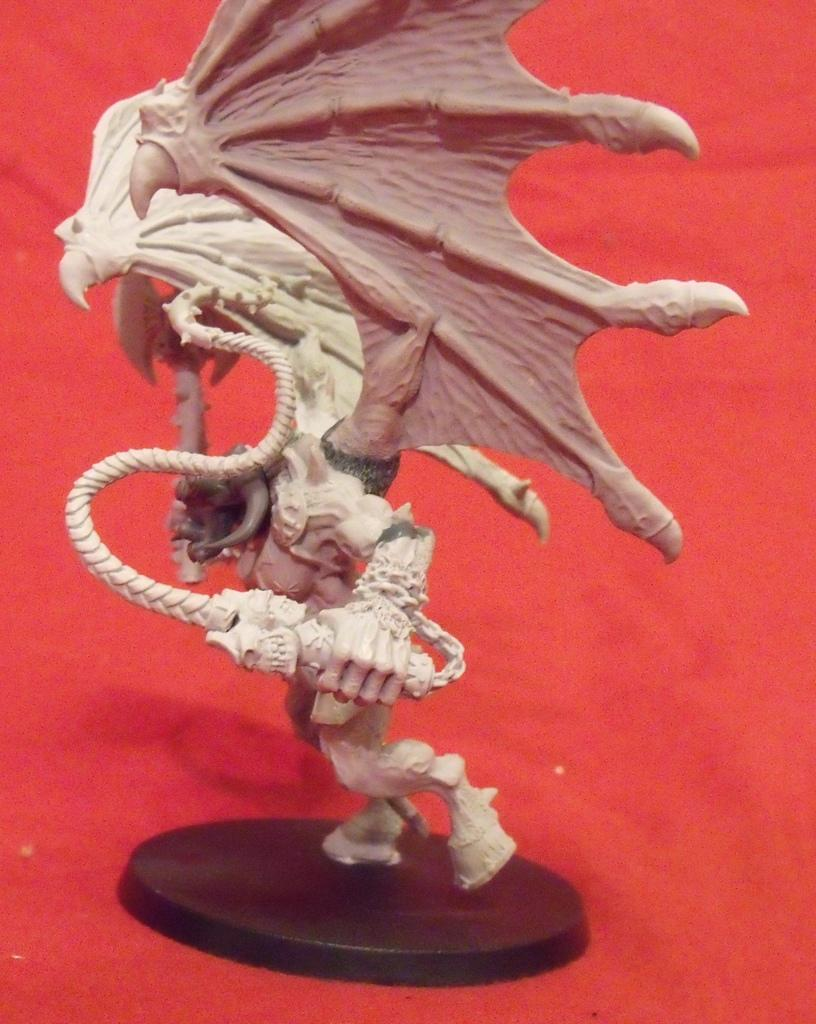What is the main subject of the image? There is a sculpture in the image. What is the sculpture placed on? The sculpture is on a red color mat. What type of trail can be seen in the image? There is no trail present in the image; it features a sculpture on a red color mat. Which direction is the sun facing in the image? There is no sun present in the image, as it focuses on a sculpture on a red color mat. 